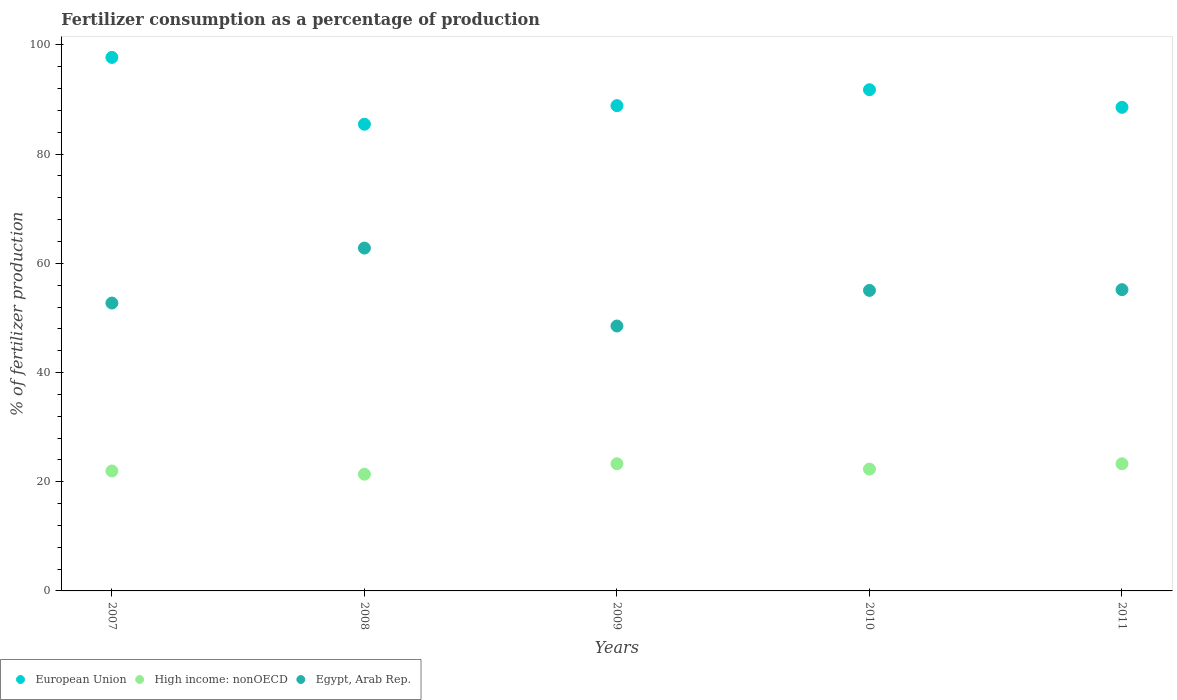How many different coloured dotlines are there?
Ensure brevity in your answer.  3. What is the percentage of fertilizers consumed in High income: nonOECD in 2009?
Offer a very short reply. 23.29. Across all years, what is the maximum percentage of fertilizers consumed in Egypt, Arab Rep.?
Provide a succinct answer. 62.8. Across all years, what is the minimum percentage of fertilizers consumed in Egypt, Arab Rep.?
Your answer should be compact. 48.52. In which year was the percentage of fertilizers consumed in Egypt, Arab Rep. minimum?
Offer a terse response. 2009. What is the total percentage of fertilizers consumed in Egypt, Arab Rep. in the graph?
Offer a very short reply. 274.27. What is the difference between the percentage of fertilizers consumed in European Union in 2008 and that in 2011?
Provide a succinct answer. -3.1. What is the difference between the percentage of fertilizers consumed in High income: nonOECD in 2011 and the percentage of fertilizers consumed in Egypt, Arab Rep. in 2010?
Make the answer very short. -31.75. What is the average percentage of fertilizers consumed in Egypt, Arab Rep. per year?
Give a very brief answer. 54.85. In the year 2007, what is the difference between the percentage of fertilizers consumed in European Union and percentage of fertilizers consumed in High income: nonOECD?
Offer a very short reply. 75.75. In how many years, is the percentage of fertilizers consumed in High income: nonOECD greater than 56 %?
Offer a terse response. 0. What is the ratio of the percentage of fertilizers consumed in High income: nonOECD in 2009 to that in 2010?
Ensure brevity in your answer.  1.04. Is the difference between the percentage of fertilizers consumed in European Union in 2007 and 2010 greater than the difference between the percentage of fertilizers consumed in High income: nonOECD in 2007 and 2010?
Provide a succinct answer. Yes. What is the difference between the highest and the second highest percentage of fertilizers consumed in European Union?
Your response must be concise. 5.92. What is the difference between the highest and the lowest percentage of fertilizers consumed in High income: nonOECD?
Your answer should be compact. 1.91. Is the sum of the percentage of fertilizers consumed in European Union in 2010 and 2011 greater than the maximum percentage of fertilizers consumed in High income: nonOECD across all years?
Keep it short and to the point. Yes. Is it the case that in every year, the sum of the percentage of fertilizers consumed in Egypt, Arab Rep. and percentage of fertilizers consumed in High income: nonOECD  is greater than the percentage of fertilizers consumed in European Union?
Ensure brevity in your answer.  No. Does the percentage of fertilizers consumed in European Union monotonically increase over the years?
Offer a very short reply. No. Is the percentage of fertilizers consumed in European Union strictly greater than the percentage of fertilizers consumed in High income: nonOECD over the years?
Ensure brevity in your answer.  Yes. Is the percentage of fertilizers consumed in High income: nonOECD strictly less than the percentage of fertilizers consumed in Egypt, Arab Rep. over the years?
Provide a succinct answer. Yes. What is the difference between two consecutive major ticks on the Y-axis?
Give a very brief answer. 20. How many legend labels are there?
Provide a succinct answer. 3. What is the title of the graph?
Make the answer very short. Fertilizer consumption as a percentage of production. What is the label or title of the Y-axis?
Offer a terse response. % of fertilizer production. What is the % of fertilizer production of European Union in 2007?
Offer a terse response. 97.72. What is the % of fertilizer production of High income: nonOECD in 2007?
Your response must be concise. 21.97. What is the % of fertilizer production in Egypt, Arab Rep. in 2007?
Your answer should be very brief. 52.73. What is the % of fertilizer production in European Union in 2008?
Offer a very short reply. 85.48. What is the % of fertilizer production of High income: nonOECD in 2008?
Your answer should be compact. 21.38. What is the % of fertilizer production in Egypt, Arab Rep. in 2008?
Provide a succinct answer. 62.8. What is the % of fertilizer production of European Union in 2009?
Provide a short and direct response. 88.88. What is the % of fertilizer production in High income: nonOECD in 2009?
Offer a very short reply. 23.29. What is the % of fertilizer production in Egypt, Arab Rep. in 2009?
Your response must be concise. 48.52. What is the % of fertilizer production of European Union in 2010?
Offer a very short reply. 91.8. What is the % of fertilizer production of High income: nonOECD in 2010?
Offer a terse response. 22.32. What is the % of fertilizer production of Egypt, Arab Rep. in 2010?
Ensure brevity in your answer.  55.04. What is the % of fertilizer production of European Union in 2011?
Give a very brief answer. 88.58. What is the % of fertilizer production of High income: nonOECD in 2011?
Make the answer very short. 23.29. What is the % of fertilizer production of Egypt, Arab Rep. in 2011?
Give a very brief answer. 55.18. Across all years, what is the maximum % of fertilizer production of European Union?
Keep it short and to the point. 97.72. Across all years, what is the maximum % of fertilizer production of High income: nonOECD?
Keep it short and to the point. 23.29. Across all years, what is the maximum % of fertilizer production in Egypt, Arab Rep.?
Offer a very short reply. 62.8. Across all years, what is the minimum % of fertilizer production in European Union?
Offer a very short reply. 85.48. Across all years, what is the minimum % of fertilizer production in High income: nonOECD?
Make the answer very short. 21.38. Across all years, what is the minimum % of fertilizer production of Egypt, Arab Rep.?
Provide a succinct answer. 48.52. What is the total % of fertilizer production in European Union in the graph?
Keep it short and to the point. 452.46. What is the total % of fertilizer production in High income: nonOECD in the graph?
Provide a succinct answer. 112.25. What is the total % of fertilizer production in Egypt, Arab Rep. in the graph?
Provide a succinct answer. 274.27. What is the difference between the % of fertilizer production of European Union in 2007 and that in 2008?
Your response must be concise. 12.24. What is the difference between the % of fertilizer production of High income: nonOECD in 2007 and that in 2008?
Give a very brief answer. 0.59. What is the difference between the % of fertilizer production of Egypt, Arab Rep. in 2007 and that in 2008?
Offer a very short reply. -10.07. What is the difference between the % of fertilizer production in European Union in 2007 and that in 2009?
Ensure brevity in your answer.  8.84. What is the difference between the % of fertilizer production in High income: nonOECD in 2007 and that in 2009?
Give a very brief answer. -1.33. What is the difference between the % of fertilizer production of Egypt, Arab Rep. in 2007 and that in 2009?
Make the answer very short. 4.21. What is the difference between the % of fertilizer production in European Union in 2007 and that in 2010?
Offer a terse response. 5.92. What is the difference between the % of fertilizer production in High income: nonOECD in 2007 and that in 2010?
Offer a terse response. -0.35. What is the difference between the % of fertilizer production in Egypt, Arab Rep. in 2007 and that in 2010?
Ensure brevity in your answer.  -2.31. What is the difference between the % of fertilizer production in European Union in 2007 and that in 2011?
Your answer should be very brief. 9.14. What is the difference between the % of fertilizer production of High income: nonOECD in 2007 and that in 2011?
Provide a succinct answer. -1.32. What is the difference between the % of fertilizer production of Egypt, Arab Rep. in 2007 and that in 2011?
Keep it short and to the point. -2.45. What is the difference between the % of fertilizer production of European Union in 2008 and that in 2009?
Provide a succinct answer. -3.4. What is the difference between the % of fertilizer production in High income: nonOECD in 2008 and that in 2009?
Provide a succinct answer. -1.91. What is the difference between the % of fertilizer production in Egypt, Arab Rep. in 2008 and that in 2009?
Provide a short and direct response. 14.28. What is the difference between the % of fertilizer production in European Union in 2008 and that in 2010?
Your response must be concise. -6.32. What is the difference between the % of fertilizer production of High income: nonOECD in 2008 and that in 2010?
Ensure brevity in your answer.  -0.94. What is the difference between the % of fertilizer production in Egypt, Arab Rep. in 2008 and that in 2010?
Provide a succinct answer. 7.76. What is the difference between the % of fertilizer production in European Union in 2008 and that in 2011?
Give a very brief answer. -3.1. What is the difference between the % of fertilizer production in High income: nonOECD in 2008 and that in 2011?
Provide a succinct answer. -1.91. What is the difference between the % of fertilizer production of Egypt, Arab Rep. in 2008 and that in 2011?
Your answer should be very brief. 7.62. What is the difference between the % of fertilizer production of European Union in 2009 and that in 2010?
Ensure brevity in your answer.  -2.92. What is the difference between the % of fertilizer production of Egypt, Arab Rep. in 2009 and that in 2010?
Offer a terse response. -6.52. What is the difference between the % of fertilizer production of European Union in 2009 and that in 2011?
Your answer should be compact. 0.31. What is the difference between the % of fertilizer production in High income: nonOECD in 2009 and that in 2011?
Make the answer very short. 0. What is the difference between the % of fertilizer production of Egypt, Arab Rep. in 2009 and that in 2011?
Offer a terse response. -6.66. What is the difference between the % of fertilizer production of European Union in 2010 and that in 2011?
Keep it short and to the point. 3.22. What is the difference between the % of fertilizer production of High income: nonOECD in 2010 and that in 2011?
Provide a succinct answer. -0.97. What is the difference between the % of fertilizer production of Egypt, Arab Rep. in 2010 and that in 2011?
Your answer should be compact. -0.14. What is the difference between the % of fertilizer production of European Union in 2007 and the % of fertilizer production of High income: nonOECD in 2008?
Ensure brevity in your answer.  76.34. What is the difference between the % of fertilizer production in European Union in 2007 and the % of fertilizer production in Egypt, Arab Rep. in 2008?
Keep it short and to the point. 34.92. What is the difference between the % of fertilizer production of High income: nonOECD in 2007 and the % of fertilizer production of Egypt, Arab Rep. in 2008?
Your response must be concise. -40.83. What is the difference between the % of fertilizer production of European Union in 2007 and the % of fertilizer production of High income: nonOECD in 2009?
Offer a terse response. 74.43. What is the difference between the % of fertilizer production in European Union in 2007 and the % of fertilizer production in Egypt, Arab Rep. in 2009?
Offer a terse response. 49.2. What is the difference between the % of fertilizer production in High income: nonOECD in 2007 and the % of fertilizer production in Egypt, Arab Rep. in 2009?
Give a very brief answer. -26.56. What is the difference between the % of fertilizer production of European Union in 2007 and the % of fertilizer production of High income: nonOECD in 2010?
Your answer should be very brief. 75.4. What is the difference between the % of fertilizer production in European Union in 2007 and the % of fertilizer production in Egypt, Arab Rep. in 2010?
Offer a very short reply. 42.68. What is the difference between the % of fertilizer production in High income: nonOECD in 2007 and the % of fertilizer production in Egypt, Arab Rep. in 2010?
Provide a succinct answer. -33.08. What is the difference between the % of fertilizer production of European Union in 2007 and the % of fertilizer production of High income: nonOECD in 2011?
Offer a very short reply. 74.43. What is the difference between the % of fertilizer production in European Union in 2007 and the % of fertilizer production in Egypt, Arab Rep. in 2011?
Provide a succinct answer. 42.54. What is the difference between the % of fertilizer production of High income: nonOECD in 2007 and the % of fertilizer production of Egypt, Arab Rep. in 2011?
Offer a terse response. -33.21. What is the difference between the % of fertilizer production of European Union in 2008 and the % of fertilizer production of High income: nonOECD in 2009?
Give a very brief answer. 62.19. What is the difference between the % of fertilizer production of European Union in 2008 and the % of fertilizer production of Egypt, Arab Rep. in 2009?
Provide a short and direct response. 36.96. What is the difference between the % of fertilizer production of High income: nonOECD in 2008 and the % of fertilizer production of Egypt, Arab Rep. in 2009?
Provide a short and direct response. -27.14. What is the difference between the % of fertilizer production in European Union in 2008 and the % of fertilizer production in High income: nonOECD in 2010?
Provide a succinct answer. 63.16. What is the difference between the % of fertilizer production in European Union in 2008 and the % of fertilizer production in Egypt, Arab Rep. in 2010?
Offer a terse response. 30.44. What is the difference between the % of fertilizer production in High income: nonOECD in 2008 and the % of fertilizer production in Egypt, Arab Rep. in 2010?
Make the answer very short. -33.66. What is the difference between the % of fertilizer production of European Union in 2008 and the % of fertilizer production of High income: nonOECD in 2011?
Give a very brief answer. 62.19. What is the difference between the % of fertilizer production of European Union in 2008 and the % of fertilizer production of Egypt, Arab Rep. in 2011?
Your answer should be very brief. 30.3. What is the difference between the % of fertilizer production in High income: nonOECD in 2008 and the % of fertilizer production in Egypt, Arab Rep. in 2011?
Provide a succinct answer. -33.8. What is the difference between the % of fertilizer production of European Union in 2009 and the % of fertilizer production of High income: nonOECD in 2010?
Give a very brief answer. 66.57. What is the difference between the % of fertilizer production in European Union in 2009 and the % of fertilizer production in Egypt, Arab Rep. in 2010?
Give a very brief answer. 33.84. What is the difference between the % of fertilizer production of High income: nonOECD in 2009 and the % of fertilizer production of Egypt, Arab Rep. in 2010?
Your response must be concise. -31.75. What is the difference between the % of fertilizer production in European Union in 2009 and the % of fertilizer production in High income: nonOECD in 2011?
Your response must be concise. 65.59. What is the difference between the % of fertilizer production in European Union in 2009 and the % of fertilizer production in Egypt, Arab Rep. in 2011?
Your response must be concise. 33.71. What is the difference between the % of fertilizer production in High income: nonOECD in 2009 and the % of fertilizer production in Egypt, Arab Rep. in 2011?
Your answer should be compact. -31.89. What is the difference between the % of fertilizer production in European Union in 2010 and the % of fertilizer production in High income: nonOECD in 2011?
Provide a short and direct response. 68.51. What is the difference between the % of fertilizer production of European Union in 2010 and the % of fertilizer production of Egypt, Arab Rep. in 2011?
Keep it short and to the point. 36.62. What is the difference between the % of fertilizer production in High income: nonOECD in 2010 and the % of fertilizer production in Egypt, Arab Rep. in 2011?
Provide a short and direct response. -32.86. What is the average % of fertilizer production of European Union per year?
Keep it short and to the point. 90.49. What is the average % of fertilizer production in High income: nonOECD per year?
Provide a short and direct response. 22.45. What is the average % of fertilizer production of Egypt, Arab Rep. per year?
Provide a succinct answer. 54.85. In the year 2007, what is the difference between the % of fertilizer production of European Union and % of fertilizer production of High income: nonOECD?
Offer a very short reply. 75.75. In the year 2007, what is the difference between the % of fertilizer production of European Union and % of fertilizer production of Egypt, Arab Rep.?
Your answer should be compact. 44.99. In the year 2007, what is the difference between the % of fertilizer production in High income: nonOECD and % of fertilizer production in Egypt, Arab Rep.?
Keep it short and to the point. -30.76. In the year 2008, what is the difference between the % of fertilizer production in European Union and % of fertilizer production in High income: nonOECD?
Give a very brief answer. 64.1. In the year 2008, what is the difference between the % of fertilizer production in European Union and % of fertilizer production in Egypt, Arab Rep.?
Provide a succinct answer. 22.68. In the year 2008, what is the difference between the % of fertilizer production of High income: nonOECD and % of fertilizer production of Egypt, Arab Rep.?
Ensure brevity in your answer.  -41.42. In the year 2009, what is the difference between the % of fertilizer production of European Union and % of fertilizer production of High income: nonOECD?
Provide a short and direct response. 65.59. In the year 2009, what is the difference between the % of fertilizer production in European Union and % of fertilizer production in Egypt, Arab Rep.?
Your answer should be compact. 40.36. In the year 2009, what is the difference between the % of fertilizer production in High income: nonOECD and % of fertilizer production in Egypt, Arab Rep.?
Offer a very short reply. -25.23. In the year 2010, what is the difference between the % of fertilizer production in European Union and % of fertilizer production in High income: nonOECD?
Your answer should be very brief. 69.48. In the year 2010, what is the difference between the % of fertilizer production in European Union and % of fertilizer production in Egypt, Arab Rep.?
Make the answer very short. 36.76. In the year 2010, what is the difference between the % of fertilizer production in High income: nonOECD and % of fertilizer production in Egypt, Arab Rep.?
Offer a very short reply. -32.73. In the year 2011, what is the difference between the % of fertilizer production in European Union and % of fertilizer production in High income: nonOECD?
Ensure brevity in your answer.  65.29. In the year 2011, what is the difference between the % of fertilizer production of European Union and % of fertilizer production of Egypt, Arab Rep.?
Give a very brief answer. 33.4. In the year 2011, what is the difference between the % of fertilizer production in High income: nonOECD and % of fertilizer production in Egypt, Arab Rep.?
Offer a very short reply. -31.89. What is the ratio of the % of fertilizer production of European Union in 2007 to that in 2008?
Provide a short and direct response. 1.14. What is the ratio of the % of fertilizer production in High income: nonOECD in 2007 to that in 2008?
Ensure brevity in your answer.  1.03. What is the ratio of the % of fertilizer production in Egypt, Arab Rep. in 2007 to that in 2008?
Give a very brief answer. 0.84. What is the ratio of the % of fertilizer production of European Union in 2007 to that in 2009?
Offer a very short reply. 1.1. What is the ratio of the % of fertilizer production in High income: nonOECD in 2007 to that in 2009?
Give a very brief answer. 0.94. What is the ratio of the % of fertilizer production of Egypt, Arab Rep. in 2007 to that in 2009?
Ensure brevity in your answer.  1.09. What is the ratio of the % of fertilizer production of European Union in 2007 to that in 2010?
Provide a succinct answer. 1.06. What is the ratio of the % of fertilizer production of High income: nonOECD in 2007 to that in 2010?
Provide a short and direct response. 0.98. What is the ratio of the % of fertilizer production of Egypt, Arab Rep. in 2007 to that in 2010?
Offer a very short reply. 0.96. What is the ratio of the % of fertilizer production of European Union in 2007 to that in 2011?
Keep it short and to the point. 1.1. What is the ratio of the % of fertilizer production of High income: nonOECD in 2007 to that in 2011?
Offer a terse response. 0.94. What is the ratio of the % of fertilizer production in Egypt, Arab Rep. in 2007 to that in 2011?
Provide a succinct answer. 0.96. What is the ratio of the % of fertilizer production in European Union in 2008 to that in 2009?
Your response must be concise. 0.96. What is the ratio of the % of fertilizer production of High income: nonOECD in 2008 to that in 2009?
Provide a succinct answer. 0.92. What is the ratio of the % of fertilizer production in Egypt, Arab Rep. in 2008 to that in 2009?
Keep it short and to the point. 1.29. What is the ratio of the % of fertilizer production of European Union in 2008 to that in 2010?
Give a very brief answer. 0.93. What is the ratio of the % of fertilizer production of High income: nonOECD in 2008 to that in 2010?
Your response must be concise. 0.96. What is the ratio of the % of fertilizer production of Egypt, Arab Rep. in 2008 to that in 2010?
Your answer should be very brief. 1.14. What is the ratio of the % of fertilizer production of European Union in 2008 to that in 2011?
Give a very brief answer. 0.96. What is the ratio of the % of fertilizer production of High income: nonOECD in 2008 to that in 2011?
Make the answer very short. 0.92. What is the ratio of the % of fertilizer production of Egypt, Arab Rep. in 2008 to that in 2011?
Give a very brief answer. 1.14. What is the ratio of the % of fertilizer production of European Union in 2009 to that in 2010?
Keep it short and to the point. 0.97. What is the ratio of the % of fertilizer production of High income: nonOECD in 2009 to that in 2010?
Your answer should be compact. 1.04. What is the ratio of the % of fertilizer production of Egypt, Arab Rep. in 2009 to that in 2010?
Ensure brevity in your answer.  0.88. What is the ratio of the % of fertilizer production in Egypt, Arab Rep. in 2009 to that in 2011?
Keep it short and to the point. 0.88. What is the ratio of the % of fertilizer production in European Union in 2010 to that in 2011?
Keep it short and to the point. 1.04. What is the ratio of the % of fertilizer production in High income: nonOECD in 2010 to that in 2011?
Provide a succinct answer. 0.96. What is the ratio of the % of fertilizer production of Egypt, Arab Rep. in 2010 to that in 2011?
Provide a succinct answer. 1. What is the difference between the highest and the second highest % of fertilizer production of European Union?
Offer a terse response. 5.92. What is the difference between the highest and the second highest % of fertilizer production of High income: nonOECD?
Your answer should be compact. 0. What is the difference between the highest and the second highest % of fertilizer production in Egypt, Arab Rep.?
Offer a very short reply. 7.62. What is the difference between the highest and the lowest % of fertilizer production in European Union?
Offer a very short reply. 12.24. What is the difference between the highest and the lowest % of fertilizer production of High income: nonOECD?
Your answer should be very brief. 1.91. What is the difference between the highest and the lowest % of fertilizer production in Egypt, Arab Rep.?
Your response must be concise. 14.28. 